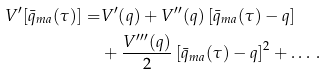Convert formula to latex. <formula><loc_0><loc_0><loc_500><loc_500>V ^ { \prime } [ \bar { q } _ { m a } ( \tau ) ] = & V ^ { \prime } ( q ) + V ^ { \prime \prime } ( q ) \left [ \bar { q } _ { m a } ( \tau ) - q \right ] \\ & + \frac { V ^ { \prime \prime \prime } ( q ) } { 2 } \left [ \bar { q } _ { m a } ( \tau ) - q \right ] ^ { 2 } + \dots \, .</formula> 